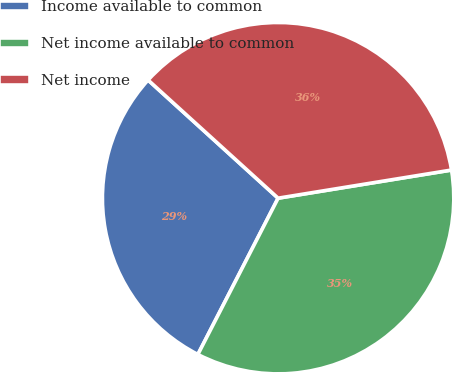<chart> <loc_0><loc_0><loc_500><loc_500><pie_chart><fcel>Income available to common<fcel>Net income available to common<fcel>Net income<nl><fcel>29.19%<fcel>35.11%<fcel>35.7%<nl></chart> 